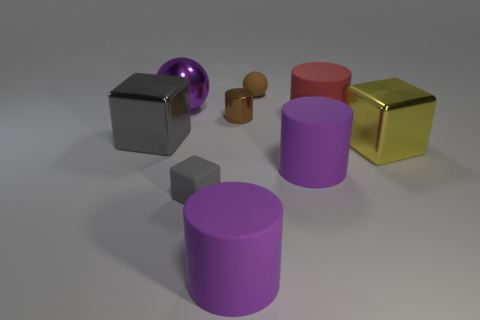Is the material of the gray cube on the right side of the big gray metallic cube the same as the small brown thing that is in front of the small rubber sphere?
Ensure brevity in your answer.  No. Is the number of tiny gray cubes that are on the right side of the small cylinder greater than the number of purple matte things behind the big red cylinder?
Your response must be concise. No. There is a brown object that is the same size as the brown sphere; what shape is it?
Ensure brevity in your answer.  Cylinder. How many things are small red rubber blocks or large shiny cubes in front of the gray metallic object?
Your answer should be very brief. 1. Does the small metallic cylinder have the same color as the big ball?
Provide a short and direct response. No. What number of tiny brown rubber spheres are in front of the large red object?
Provide a succinct answer. 0. What color is the other cube that is the same material as the yellow cube?
Give a very brief answer. Gray. What number of matte objects are either purple cylinders or red objects?
Your response must be concise. 3. Are the tiny brown cylinder and the large purple ball made of the same material?
Your response must be concise. Yes. What is the shape of the large purple thing that is to the right of the small brown sphere?
Your answer should be very brief. Cylinder. 